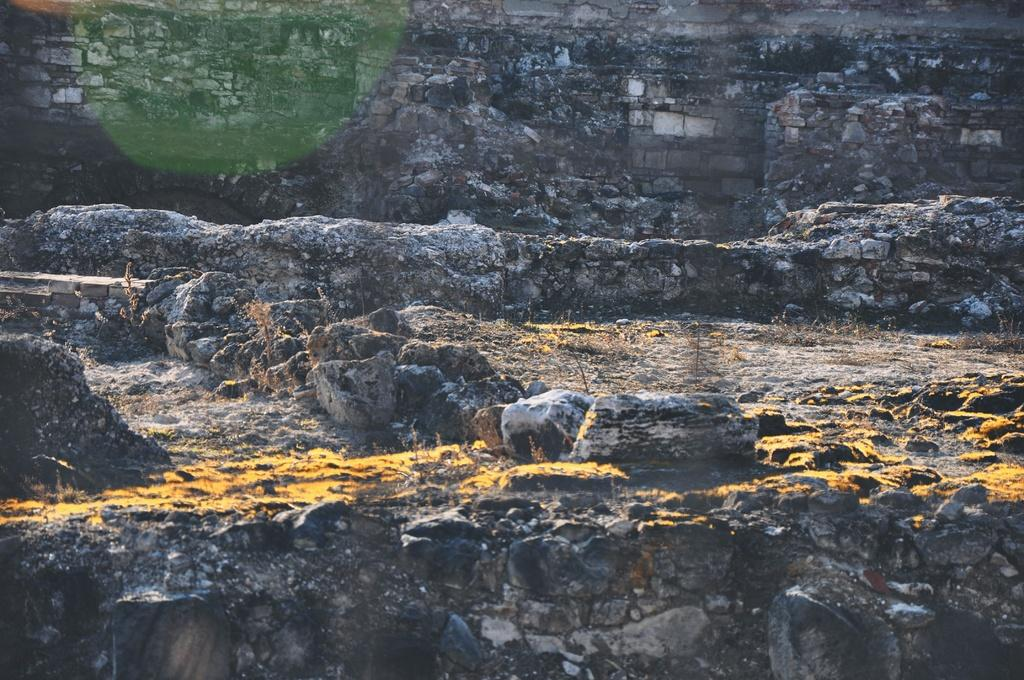What type of natural elements can be seen in the image? There are rocks in the image. What is covering the surface of the rocks? There is dried grass on the surface of the rocks. What can be seen in the background of the image? There is a rock wall in the background of the image. Reasoning: Let's think step by step by step in order to produce the conversation. We start by identifying the main subject in the image, which is the rocks. Then, we expand the conversation to include other details about the rocks, such as the dried grass on their surface. Finally, we mention the rock wall in the background to provide a sense of the overall setting. Absurd Question/Answer: What type of behavior can be observed in the rocks in the image? Rocks do not exhibit behavior, as they are inanimate objects. 